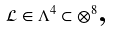Convert formula to latex. <formula><loc_0><loc_0><loc_500><loc_500>\mathcal { L } \in \Lambda ^ { 4 } \subset \otimes ^ { 8 } \text {,}</formula> 